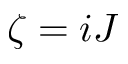Convert formula to latex. <formula><loc_0><loc_0><loc_500><loc_500>\zeta = i J</formula> 